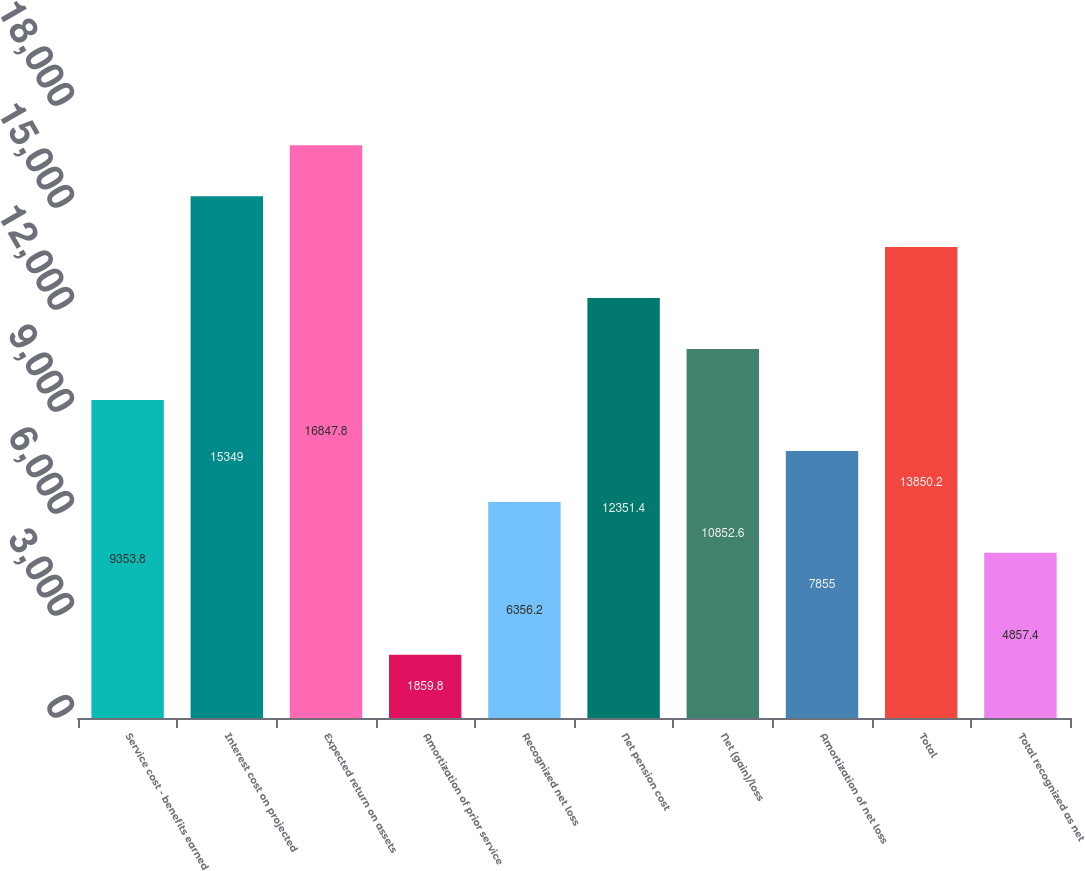<chart> <loc_0><loc_0><loc_500><loc_500><bar_chart><fcel>Service cost - benefits earned<fcel>Interest cost on projected<fcel>Expected return on assets<fcel>Amortization of prior service<fcel>Recognized net loss<fcel>Net pension cost<fcel>Net (gain)/loss<fcel>Amortization of net loss<fcel>Total<fcel>Total recognized as net<nl><fcel>9353.8<fcel>15349<fcel>16847.8<fcel>1859.8<fcel>6356.2<fcel>12351.4<fcel>10852.6<fcel>7855<fcel>13850.2<fcel>4857.4<nl></chart> 